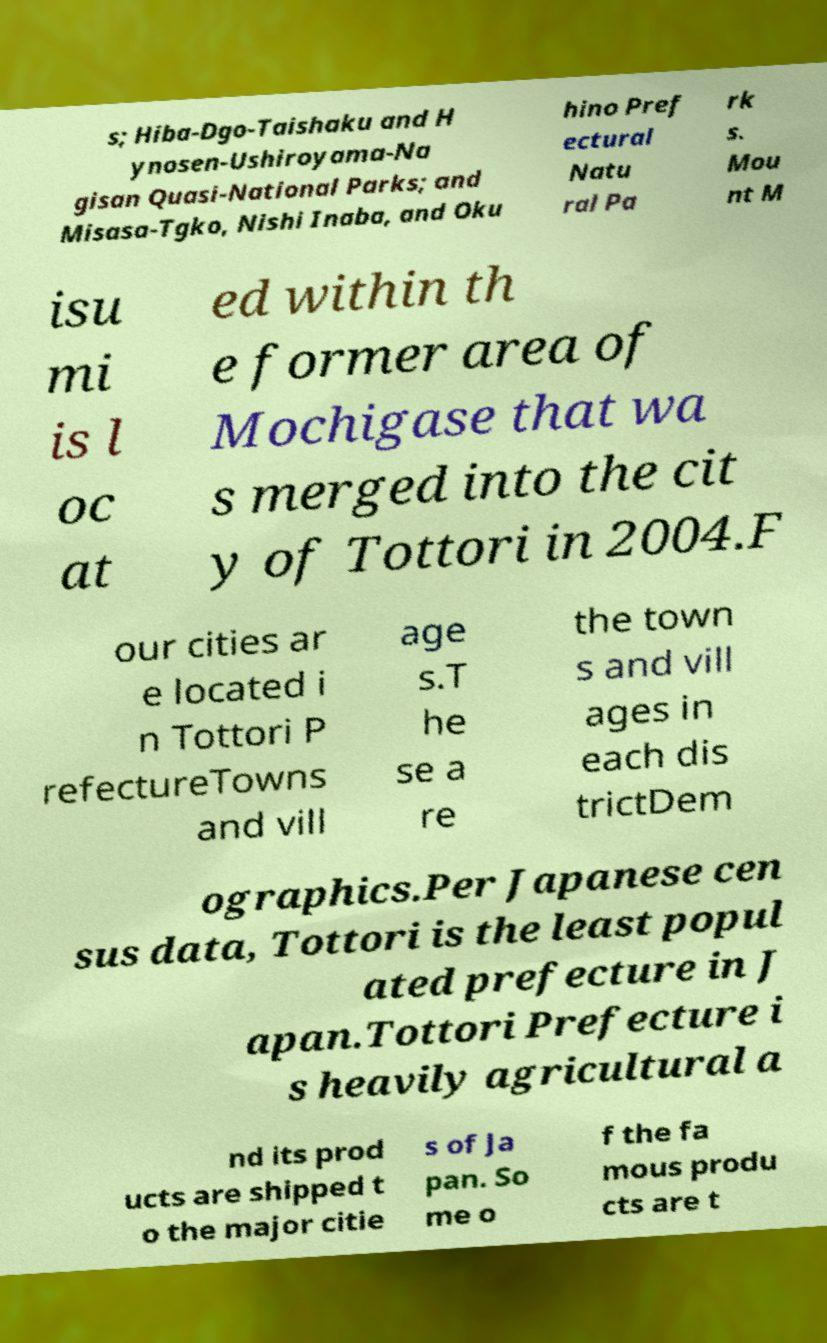Could you assist in decoding the text presented in this image and type it out clearly? s; Hiba-Dgo-Taishaku and H ynosen-Ushiroyama-Na gisan Quasi-National Parks; and Misasa-Tgko, Nishi Inaba, and Oku hino Pref ectural Natu ral Pa rk s. Mou nt M isu mi is l oc at ed within th e former area of Mochigase that wa s merged into the cit y of Tottori in 2004.F our cities ar e located i n Tottori P refectureTowns and vill age s.T he se a re the town s and vill ages in each dis trictDem ographics.Per Japanese cen sus data, Tottori is the least popul ated prefecture in J apan.Tottori Prefecture i s heavily agricultural a nd its prod ucts are shipped t o the major citie s of Ja pan. So me o f the fa mous produ cts are t 